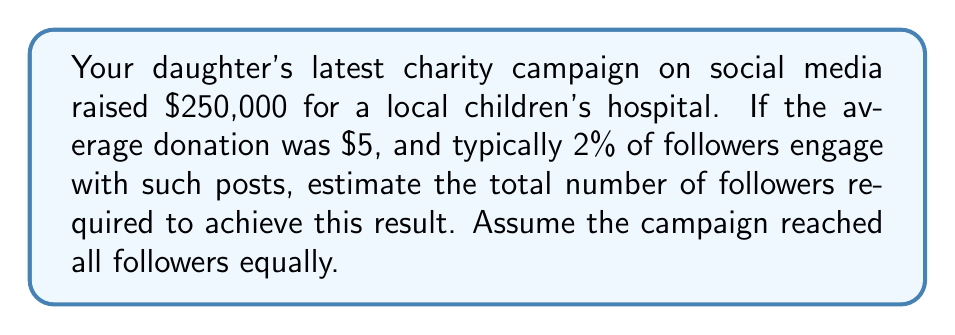Can you answer this question? Let's approach this step-by-step:

1) First, let's calculate the number of people who donated:
   $$\text{Number of donors} = \frac{\text{Total amount raised}}{\text{Average donation}}$$
   $$\text{Number of donors} = \frac{\$250,000}{\$5} = 50,000$$

2) We know that typically 2% of followers engage with such posts. This means that the number of donors represents 2% of the total followers.

3) To find the total number of followers, we need to solve this equation:
   $$50,000 = 0.02x$$
   Where $x$ is the total number of followers.

4) Solving for $x$:
   $$x = \frac{50,000}{0.02} = 2,500,000$$

Therefore, to achieve this result, your daughter would need approximately 2.5 million followers, assuming the campaign reached all followers equally and the engagement rate was exactly 2%.
Answer: 2,500,000 followers 